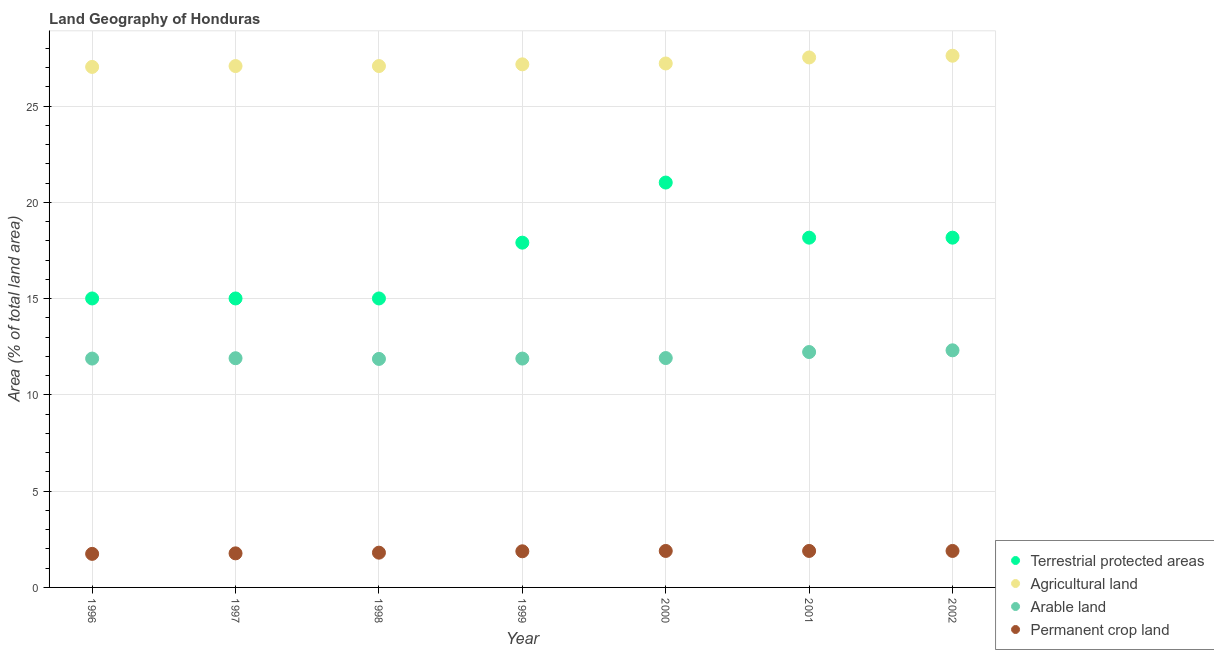How many different coloured dotlines are there?
Give a very brief answer. 4. What is the percentage of area under permanent crop land in 1997?
Offer a very short reply. 1.77. Across all years, what is the maximum percentage of area under arable land?
Your answer should be very brief. 12.32. Across all years, what is the minimum percentage of land under terrestrial protection?
Provide a short and direct response. 15.01. In which year was the percentage of area under agricultural land maximum?
Offer a very short reply. 2002. In which year was the percentage of area under permanent crop land minimum?
Provide a short and direct response. 1996. What is the total percentage of land under terrestrial protection in the graph?
Your answer should be very brief. 120.3. What is the difference between the percentage of area under arable land in 1998 and that in 2001?
Provide a succinct answer. -0.36. What is the difference between the percentage of area under permanent crop land in 1996 and the percentage of land under terrestrial protection in 1998?
Make the answer very short. -13.27. What is the average percentage of land under terrestrial protection per year?
Offer a terse response. 17.19. In the year 1999, what is the difference between the percentage of land under terrestrial protection and percentage of area under arable land?
Make the answer very short. 6.02. In how many years, is the percentage of area under permanent crop land greater than 16 %?
Make the answer very short. 0. What is the ratio of the percentage of area under permanent crop land in 1998 to that in 2001?
Your answer should be very brief. 0.95. Is the difference between the percentage of land under terrestrial protection in 1997 and 2001 greater than the difference between the percentage of area under agricultural land in 1997 and 2001?
Ensure brevity in your answer.  No. What is the difference between the highest and the second highest percentage of land under terrestrial protection?
Provide a succinct answer. 2.86. What is the difference between the highest and the lowest percentage of land under terrestrial protection?
Ensure brevity in your answer.  6.02. Is it the case that in every year, the sum of the percentage of land under terrestrial protection and percentage of area under permanent crop land is greater than the sum of percentage of area under agricultural land and percentage of area under arable land?
Offer a terse response. No. Is it the case that in every year, the sum of the percentage of land under terrestrial protection and percentage of area under agricultural land is greater than the percentage of area under arable land?
Make the answer very short. Yes. Does the percentage of area under arable land monotonically increase over the years?
Give a very brief answer. No. Is the percentage of land under terrestrial protection strictly less than the percentage of area under permanent crop land over the years?
Give a very brief answer. No. What is the difference between two consecutive major ticks on the Y-axis?
Your answer should be very brief. 5. Does the graph contain any zero values?
Make the answer very short. No. Does the graph contain grids?
Give a very brief answer. Yes. Where does the legend appear in the graph?
Ensure brevity in your answer.  Bottom right. How many legend labels are there?
Provide a short and direct response. 4. How are the legend labels stacked?
Ensure brevity in your answer.  Vertical. What is the title of the graph?
Keep it short and to the point. Land Geography of Honduras. What is the label or title of the X-axis?
Make the answer very short. Year. What is the label or title of the Y-axis?
Give a very brief answer. Area (% of total land area). What is the Area (% of total land area) of Terrestrial protected areas in 1996?
Offer a terse response. 15.01. What is the Area (% of total land area) in Agricultural land in 1996?
Make the answer very short. 27.04. What is the Area (% of total land area) of Arable land in 1996?
Your answer should be very brief. 11.89. What is the Area (% of total land area) in Permanent crop land in 1996?
Your answer should be very brief. 1.74. What is the Area (% of total land area) of Terrestrial protected areas in 1997?
Ensure brevity in your answer.  15.01. What is the Area (% of total land area) in Agricultural land in 1997?
Offer a terse response. 27.08. What is the Area (% of total land area) in Arable land in 1997?
Offer a terse response. 11.9. What is the Area (% of total land area) in Permanent crop land in 1997?
Provide a succinct answer. 1.77. What is the Area (% of total land area) of Terrestrial protected areas in 1998?
Ensure brevity in your answer.  15.01. What is the Area (% of total land area) of Agricultural land in 1998?
Give a very brief answer. 27.08. What is the Area (% of total land area) in Arable land in 1998?
Provide a succinct answer. 11.87. What is the Area (% of total land area) of Permanent crop land in 1998?
Make the answer very short. 1.81. What is the Area (% of total land area) of Terrestrial protected areas in 1999?
Your response must be concise. 17.91. What is the Area (% of total land area) in Agricultural land in 1999?
Give a very brief answer. 27.17. What is the Area (% of total land area) of Arable land in 1999?
Ensure brevity in your answer.  11.89. What is the Area (% of total land area) of Permanent crop land in 1999?
Provide a short and direct response. 1.88. What is the Area (% of total land area) in Terrestrial protected areas in 2000?
Make the answer very short. 21.03. What is the Area (% of total land area) in Agricultural land in 2000?
Offer a very short reply. 27.21. What is the Area (% of total land area) in Arable land in 2000?
Your answer should be very brief. 11.91. What is the Area (% of total land area) of Permanent crop land in 2000?
Your answer should be very brief. 1.89. What is the Area (% of total land area) of Terrestrial protected areas in 2001?
Give a very brief answer. 18.17. What is the Area (% of total land area) in Agricultural land in 2001?
Offer a terse response. 27.53. What is the Area (% of total land area) in Arable land in 2001?
Your answer should be very brief. 12.23. What is the Area (% of total land area) of Permanent crop land in 2001?
Keep it short and to the point. 1.89. What is the Area (% of total land area) in Terrestrial protected areas in 2002?
Give a very brief answer. 18.17. What is the Area (% of total land area) in Agricultural land in 2002?
Your answer should be compact. 27.62. What is the Area (% of total land area) of Arable land in 2002?
Your answer should be compact. 12.32. What is the Area (% of total land area) in Permanent crop land in 2002?
Your response must be concise. 1.89. Across all years, what is the maximum Area (% of total land area) in Terrestrial protected areas?
Make the answer very short. 21.03. Across all years, what is the maximum Area (% of total land area) in Agricultural land?
Keep it short and to the point. 27.62. Across all years, what is the maximum Area (% of total land area) in Arable land?
Give a very brief answer. 12.32. Across all years, what is the maximum Area (% of total land area) of Permanent crop land?
Your answer should be very brief. 1.89. Across all years, what is the minimum Area (% of total land area) of Terrestrial protected areas?
Offer a very short reply. 15.01. Across all years, what is the minimum Area (% of total land area) of Agricultural land?
Your response must be concise. 27.04. Across all years, what is the minimum Area (% of total land area) in Arable land?
Make the answer very short. 11.87. Across all years, what is the minimum Area (% of total land area) in Permanent crop land?
Your answer should be compact. 1.74. What is the total Area (% of total land area) in Terrestrial protected areas in the graph?
Provide a succinct answer. 120.3. What is the total Area (% of total land area) in Agricultural land in the graph?
Keep it short and to the point. 190.72. What is the total Area (% of total land area) of Arable land in the graph?
Give a very brief answer. 84. What is the total Area (% of total land area) in Permanent crop land in the graph?
Provide a succinct answer. 12.88. What is the difference between the Area (% of total land area) of Agricultural land in 1996 and that in 1997?
Ensure brevity in your answer.  -0.04. What is the difference between the Area (% of total land area) in Arable land in 1996 and that in 1997?
Offer a terse response. -0.02. What is the difference between the Area (% of total land area) of Permanent crop land in 1996 and that in 1997?
Provide a succinct answer. -0.03. What is the difference between the Area (% of total land area) of Terrestrial protected areas in 1996 and that in 1998?
Give a very brief answer. 0. What is the difference between the Area (% of total land area) in Agricultural land in 1996 and that in 1998?
Make the answer very short. -0.04. What is the difference between the Area (% of total land area) in Arable land in 1996 and that in 1998?
Ensure brevity in your answer.  0.02. What is the difference between the Area (% of total land area) of Permanent crop land in 1996 and that in 1998?
Offer a terse response. -0.06. What is the difference between the Area (% of total land area) of Terrestrial protected areas in 1996 and that in 1999?
Keep it short and to the point. -2.9. What is the difference between the Area (% of total land area) of Agricultural land in 1996 and that in 1999?
Your answer should be very brief. -0.13. What is the difference between the Area (% of total land area) of Permanent crop land in 1996 and that in 1999?
Your response must be concise. -0.13. What is the difference between the Area (% of total land area) of Terrestrial protected areas in 1996 and that in 2000?
Offer a very short reply. -6.02. What is the difference between the Area (% of total land area) in Agricultural land in 1996 and that in 2000?
Keep it short and to the point. -0.18. What is the difference between the Area (% of total land area) of Arable land in 1996 and that in 2000?
Your response must be concise. -0.03. What is the difference between the Area (% of total land area) of Permanent crop land in 1996 and that in 2000?
Keep it short and to the point. -0.15. What is the difference between the Area (% of total land area) of Terrestrial protected areas in 1996 and that in 2001?
Offer a terse response. -3.16. What is the difference between the Area (% of total land area) of Agricultural land in 1996 and that in 2001?
Make the answer very short. -0.49. What is the difference between the Area (% of total land area) of Arable land in 1996 and that in 2001?
Make the answer very short. -0.34. What is the difference between the Area (% of total land area) of Permanent crop land in 1996 and that in 2001?
Provide a short and direct response. -0.15. What is the difference between the Area (% of total land area) of Terrestrial protected areas in 1996 and that in 2002?
Offer a very short reply. -3.16. What is the difference between the Area (% of total land area) of Agricultural land in 1996 and that in 2002?
Give a very brief answer. -0.58. What is the difference between the Area (% of total land area) of Arable land in 1996 and that in 2002?
Your answer should be compact. -0.43. What is the difference between the Area (% of total land area) in Permanent crop land in 1996 and that in 2002?
Provide a succinct answer. -0.15. What is the difference between the Area (% of total land area) in Terrestrial protected areas in 1997 and that in 1998?
Make the answer very short. 0. What is the difference between the Area (% of total land area) in Agricultural land in 1997 and that in 1998?
Provide a short and direct response. 0. What is the difference between the Area (% of total land area) in Arable land in 1997 and that in 1998?
Keep it short and to the point. 0.04. What is the difference between the Area (% of total land area) in Permanent crop land in 1997 and that in 1998?
Offer a terse response. -0.04. What is the difference between the Area (% of total land area) in Terrestrial protected areas in 1997 and that in 1999?
Your answer should be very brief. -2.9. What is the difference between the Area (% of total land area) of Agricultural land in 1997 and that in 1999?
Offer a very short reply. -0.09. What is the difference between the Area (% of total land area) in Arable land in 1997 and that in 1999?
Your answer should be compact. 0.02. What is the difference between the Area (% of total land area) of Permanent crop land in 1997 and that in 1999?
Ensure brevity in your answer.  -0.11. What is the difference between the Area (% of total land area) in Terrestrial protected areas in 1997 and that in 2000?
Your answer should be compact. -6.02. What is the difference between the Area (% of total land area) in Agricultural land in 1997 and that in 2000?
Provide a succinct answer. -0.13. What is the difference between the Area (% of total land area) of Arable land in 1997 and that in 2000?
Your response must be concise. -0.01. What is the difference between the Area (% of total land area) of Permanent crop land in 1997 and that in 2000?
Offer a very short reply. -0.13. What is the difference between the Area (% of total land area) in Terrestrial protected areas in 1997 and that in 2001?
Your answer should be very brief. -3.16. What is the difference between the Area (% of total land area) in Agricultural land in 1997 and that in 2001?
Your answer should be very brief. -0.45. What is the difference between the Area (% of total land area) in Arable land in 1997 and that in 2001?
Your answer should be compact. -0.32. What is the difference between the Area (% of total land area) in Permanent crop land in 1997 and that in 2001?
Provide a short and direct response. -0.13. What is the difference between the Area (% of total land area) of Terrestrial protected areas in 1997 and that in 2002?
Provide a short and direct response. -3.16. What is the difference between the Area (% of total land area) of Agricultural land in 1997 and that in 2002?
Make the answer very short. -0.54. What is the difference between the Area (% of total land area) in Arable land in 1997 and that in 2002?
Offer a very short reply. -0.41. What is the difference between the Area (% of total land area) in Permanent crop land in 1997 and that in 2002?
Make the answer very short. -0.13. What is the difference between the Area (% of total land area) of Terrestrial protected areas in 1998 and that in 1999?
Ensure brevity in your answer.  -2.9. What is the difference between the Area (% of total land area) of Agricultural land in 1998 and that in 1999?
Keep it short and to the point. -0.09. What is the difference between the Area (% of total land area) in Arable land in 1998 and that in 1999?
Ensure brevity in your answer.  -0.02. What is the difference between the Area (% of total land area) in Permanent crop land in 1998 and that in 1999?
Give a very brief answer. -0.07. What is the difference between the Area (% of total land area) in Terrestrial protected areas in 1998 and that in 2000?
Provide a succinct answer. -6.02. What is the difference between the Area (% of total land area) of Agricultural land in 1998 and that in 2000?
Provide a short and direct response. -0.13. What is the difference between the Area (% of total land area) of Arable land in 1998 and that in 2000?
Give a very brief answer. -0.04. What is the difference between the Area (% of total land area) in Permanent crop land in 1998 and that in 2000?
Provide a short and direct response. -0.09. What is the difference between the Area (% of total land area) in Terrestrial protected areas in 1998 and that in 2001?
Make the answer very short. -3.16. What is the difference between the Area (% of total land area) in Agricultural land in 1998 and that in 2001?
Your answer should be compact. -0.45. What is the difference between the Area (% of total land area) in Arable land in 1998 and that in 2001?
Your answer should be very brief. -0.36. What is the difference between the Area (% of total land area) of Permanent crop land in 1998 and that in 2001?
Make the answer very short. -0.09. What is the difference between the Area (% of total land area) of Terrestrial protected areas in 1998 and that in 2002?
Offer a very short reply. -3.16. What is the difference between the Area (% of total land area) of Agricultural land in 1998 and that in 2002?
Your response must be concise. -0.54. What is the difference between the Area (% of total land area) of Arable land in 1998 and that in 2002?
Provide a short and direct response. -0.45. What is the difference between the Area (% of total land area) in Permanent crop land in 1998 and that in 2002?
Your answer should be very brief. -0.09. What is the difference between the Area (% of total land area) in Terrestrial protected areas in 1999 and that in 2000?
Your answer should be very brief. -3.12. What is the difference between the Area (% of total land area) of Agricultural land in 1999 and that in 2000?
Make the answer very short. -0.04. What is the difference between the Area (% of total land area) of Arable land in 1999 and that in 2000?
Offer a very short reply. -0.03. What is the difference between the Area (% of total land area) in Permanent crop land in 1999 and that in 2000?
Provide a short and direct response. -0.02. What is the difference between the Area (% of total land area) in Terrestrial protected areas in 1999 and that in 2001?
Keep it short and to the point. -0.26. What is the difference between the Area (% of total land area) in Agricultural land in 1999 and that in 2001?
Provide a short and direct response. -0.36. What is the difference between the Area (% of total land area) in Arable land in 1999 and that in 2001?
Your response must be concise. -0.34. What is the difference between the Area (% of total land area) in Permanent crop land in 1999 and that in 2001?
Offer a very short reply. -0.02. What is the difference between the Area (% of total land area) of Terrestrial protected areas in 1999 and that in 2002?
Offer a terse response. -0.26. What is the difference between the Area (% of total land area) of Agricultural land in 1999 and that in 2002?
Provide a succinct answer. -0.45. What is the difference between the Area (% of total land area) of Arable land in 1999 and that in 2002?
Provide a succinct answer. -0.43. What is the difference between the Area (% of total land area) of Permanent crop land in 1999 and that in 2002?
Provide a succinct answer. -0.02. What is the difference between the Area (% of total land area) of Terrestrial protected areas in 2000 and that in 2001?
Provide a succinct answer. 2.86. What is the difference between the Area (% of total land area) in Agricultural land in 2000 and that in 2001?
Keep it short and to the point. -0.31. What is the difference between the Area (% of total land area) of Arable land in 2000 and that in 2001?
Your answer should be very brief. -0.31. What is the difference between the Area (% of total land area) of Terrestrial protected areas in 2000 and that in 2002?
Provide a short and direct response. 2.86. What is the difference between the Area (% of total land area) in Agricultural land in 2000 and that in 2002?
Give a very brief answer. -0.4. What is the difference between the Area (% of total land area) in Arable land in 2000 and that in 2002?
Provide a succinct answer. -0.4. What is the difference between the Area (% of total land area) in Permanent crop land in 2000 and that in 2002?
Keep it short and to the point. 0. What is the difference between the Area (% of total land area) of Terrestrial protected areas in 2001 and that in 2002?
Your answer should be very brief. 0. What is the difference between the Area (% of total land area) of Agricultural land in 2001 and that in 2002?
Your response must be concise. -0.09. What is the difference between the Area (% of total land area) of Arable land in 2001 and that in 2002?
Your answer should be very brief. -0.09. What is the difference between the Area (% of total land area) of Terrestrial protected areas in 1996 and the Area (% of total land area) of Agricultural land in 1997?
Provide a short and direct response. -12.07. What is the difference between the Area (% of total land area) of Terrestrial protected areas in 1996 and the Area (% of total land area) of Arable land in 1997?
Keep it short and to the point. 3.1. What is the difference between the Area (% of total land area) of Terrestrial protected areas in 1996 and the Area (% of total land area) of Permanent crop land in 1997?
Make the answer very short. 13.24. What is the difference between the Area (% of total land area) of Agricultural land in 1996 and the Area (% of total land area) of Arable land in 1997?
Your answer should be compact. 15.13. What is the difference between the Area (% of total land area) in Agricultural land in 1996 and the Area (% of total land area) in Permanent crop land in 1997?
Provide a short and direct response. 25.27. What is the difference between the Area (% of total land area) of Arable land in 1996 and the Area (% of total land area) of Permanent crop land in 1997?
Ensure brevity in your answer.  10.12. What is the difference between the Area (% of total land area) in Terrestrial protected areas in 1996 and the Area (% of total land area) in Agricultural land in 1998?
Make the answer very short. -12.07. What is the difference between the Area (% of total land area) in Terrestrial protected areas in 1996 and the Area (% of total land area) in Arable land in 1998?
Offer a very short reply. 3.14. What is the difference between the Area (% of total land area) in Terrestrial protected areas in 1996 and the Area (% of total land area) in Permanent crop land in 1998?
Make the answer very short. 13.2. What is the difference between the Area (% of total land area) of Agricultural land in 1996 and the Area (% of total land area) of Arable land in 1998?
Make the answer very short. 15.17. What is the difference between the Area (% of total land area) of Agricultural land in 1996 and the Area (% of total land area) of Permanent crop land in 1998?
Make the answer very short. 25.23. What is the difference between the Area (% of total land area) in Arable land in 1996 and the Area (% of total land area) in Permanent crop land in 1998?
Keep it short and to the point. 10.08. What is the difference between the Area (% of total land area) in Terrestrial protected areas in 1996 and the Area (% of total land area) in Agricultural land in 1999?
Ensure brevity in your answer.  -12.16. What is the difference between the Area (% of total land area) in Terrestrial protected areas in 1996 and the Area (% of total land area) in Arable land in 1999?
Keep it short and to the point. 3.12. What is the difference between the Area (% of total land area) in Terrestrial protected areas in 1996 and the Area (% of total land area) in Permanent crop land in 1999?
Give a very brief answer. 13.13. What is the difference between the Area (% of total land area) in Agricultural land in 1996 and the Area (% of total land area) in Arable land in 1999?
Provide a short and direct response. 15.15. What is the difference between the Area (% of total land area) in Agricultural land in 1996 and the Area (% of total land area) in Permanent crop land in 1999?
Your response must be concise. 25.16. What is the difference between the Area (% of total land area) in Arable land in 1996 and the Area (% of total land area) in Permanent crop land in 1999?
Your answer should be compact. 10.01. What is the difference between the Area (% of total land area) of Terrestrial protected areas in 1996 and the Area (% of total land area) of Agricultural land in 2000?
Make the answer very short. -12.21. What is the difference between the Area (% of total land area) of Terrestrial protected areas in 1996 and the Area (% of total land area) of Arable land in 2000?
Your answer should be compact. 3.1. What is the difference between the Area (% of total land area) in Terrestrial protected areas in 1996 and the Area (% of total land area) in Permanent crop land in 2000?
Your response must be concise. 13.11. What is the difference between the Area (% of total land area) of Agricultural land in 1996 and the Area (% of total land area) of Arable land in 2000?
Provide a short and direct response. 15.12. What is the difference between the Area (% of total land area) of Agricultural land in 1996 and the Area (% of total land area) of Permanent crop land in 2000?
Provide a succinct answer. 25.14. What is the difference between the Area (% of total land area) of Arable land in 1996 and the Area (% of total land area) of Permanent crop land in 2000?
Keep it short and to the point. 9.99. What is the difference between the Area (% of total land area) in Terrestrial protected areas in 1996 and the Area (% of total land area) in Agricultural land in 2001?
Offer a very short reply. -12.52. What is the difference between the Area (% of total land area) in Terrestrial protected areas in 1996 and the Area (% of total land area) in Arable land in 2001?
Give a very brief answer. 2.78. What is the difference between the Area (% of total land area) in Terrestrial protected areas in 1996 and the Area (% of total land area) in Permanent crop land in 2001?
Offer a terse response. 13.11. What is the difference between the Area (% of total land area) of Agricultural land in 1996 and the Area (% of total land area) of Arable land in 2001?
Give a very brief answer. 14.81. What is the difference between the Area (% of total land area) in Agricultural land in 1996 and the Area (% of total land area) in Permanent crop land in 2001?
Provide a short and direct response. 25.14. What is the difference between the Area (% of total land area) in Arable land in 1996 and the Area (% of total land area) in Permanent crop land in 2001?
Offer a very short reply. 9.99. What is the difference between the Area (% of total land area) of Terrestrial protected areas in 1996 and the Area (% of total land area) of Agricultural land in 2002?
Make the answer very short. -12.61. What is the difference between the Area (% of total land area) of Terrestrial protected areas in 1996 and the Area (% of total land area) of Arable land in 2002?
Offer a very short reply. 2.69. What is the difference between the Area (% of total land area) of Terrestrial protected areas in 1996 and the Area (% of total land area) of Permanent crop land in 2002?
Provide a short and direct response. 13.11. What is the difference between the Area (% of total land area) in Agricultural land in 1996 and the Area (% of total land area) in Arable land in 2002?
Offer a very short reply. 14.72. What is the difference between the Area (% of total land area) of Agricultural land in 1996 and the Area (% of total land area) of Permanent crop land in 2002?
Offer a terse response. 25.14. What is the difference between the Area (% of total land area) of Arable land in 1996 and the Area (% of total land area) of Permanent crop land in 2002?
Offer a terse response. 9.99. What is the difference between the Area (% of total land area) of Terrestrial protected areas in 1997 and the Area (% of total land area) of Agricultural land in 1998?
Your response must be concise. -12.07. What is the difference between the Area (% of total land area) in Terrestrial protected areas in 1997 and the Area (% of total land area) in Arable land in 1998?
Your answer should be compact. 3.14. What is the difference between the Area (% of total land area) in Terrestrial protected areas in 1997 and the Area (% of total land area) in Permanent crop land in 1998?
Your answer should be very brief. 13.2. What is the difference between the Area (% of total land area) of Agricultural land in 1997 and the Area (% of total land area) of Arable land in 1998?
Give a very brief answer. 15.21. What is the difference between the Area (% of total land area) in Agricultural land in 1997 and the Area (% of total land area) in Permanent crop land in 1998?
Your answer should be very brief. 25.27. What is the difference between the Area (% of total land area) in Arable land in 1997 and the Area (% of total land area) in Permanent crop land in 1998?
Give a very brief answer. 10.1. What is the difference between the Area (% of total land area) of Terrestrial protected areas in 1997 and the Area (% of total land area) of Agricultural land in 1999?
Ensure brevity in your answer.  -12.16. What is the difference between the Area (% of total land area) of Terrestrial protected areas in 1997 and the Area (% of total land area) of Arable land in 1999?
Your answer should be very brief. 3.12. What is the difference between the Area (% of total land area) in Terrestrial protected areas in 1997 and the Area (% of total land area) in Permanent crop land in 1999?
Make the answer very short. 13.13. What is the difference between the Area (% of total land area) in Agricultural land in 1997 and the Area (% of total land area) in Arable land in 1999?
Provide a short and direct response. 15.19. What is the difference between the Area (% of total land area) of Agricultural land in 1997 and the Area (% of total land area) of Permanent crop land in 1999?
Provide a succinct answer. 25.2. What is the difference between the Area (% of total land area) in Arable land in 1997 and the Area (% of total land area) in Permanent crop land in 1999?
Provide a short and direct response. 10.03. What is the difference between the Area (% of total land area) in Terrestrial protected areas in 1997 and the Area (% of total land area) in Agricultural land in 2000?
Ensure brevity in your answer.  -12.21. What is the difference between the Area (% of total land area) in Terrestrial protected areas in 1997 and the Area (% of total land area) in Arable land in 2000?
Your answer should be compact. 3.1. What is the difference between the Area (% of total land area) in Terrestrial protected areas in 1997 and the Area (% of total land area) in Permanent crop land in 2000?
Your answer should be compact. 13.11. What is the difference between the Area (% of total land area) in Agricultural land in 1997 and the Area (% of total land area) in Arable land in 2000?
Give a very brief answer. 15.17. What is the difference between the Area (% of total land area) in Agricultural land in 1997 and the Area (% of total land area) in Permanent crop land in 2000?
Your response must be concise. 25.19. What is the difference between the Area (% of total land area) in Arable land in 1997 and the Area (% of total land area) in Permanent crop land in 2000?
Your answer should be very brief. 10.01. What is the difference between the Area (% of total land area) in Terrestrial protected areas in 1997 and the Area (% of total land area) in Agricultural land in 2001?
Your answer should be very brief. -12.52. What is the difference between the Area (% of total land area) in Terrestrial protected areas in 1997 and the Area (% of total land area) in Arable land in 2001?
Offer a very short reply. 2.78. What is the difference between the Area (% of total land area) of Terrestrial protected areas in 1997 and the Area (% of total land area) of Permanent crop land in 2001?
Your answer should be compact. 13.11. What is the difference between the Area (% of total land area) in Agricultural land in 1997 and the Area (% of total land area) in Arable land in 2001?
Give a very brief answer. 14.85. What is the difference between the Area (% of total land area) in Agricultural land in 1997 and the Area (% of total land area) in Permanent crop land in 2001?
Your answer should be compact. 25.19. What is the difference between the Area (% of total land area) in Arable land in 1997 and the Area (% of total land area) in Permanent crop land in 2001?
Make the answer very short. 10.01. What is the difference between the Area (% of total land area) in Terrestrial protected areas in 1997 and the Area (% of total land area) in Agricultural land in 2002?
Your answer should be compact. -12.61. What is the difference between the Area (% of total land area) of Terrestrial protected areas in 1997 and the Area (% of total land area) of Arable land in 2002?
Offer a terse response. 2.69. What is the difference between the Area (% of total land area) of Terrestrial protected areas in 1997 and the Area (% of total land area) of Permanent crop land in 2002?
Your answer should be compact. 13.11. What is the difference between the Area (% of total land area) of Agricultural land in 1997 and the Area (% of total land area) of Arable land in 2002?
Your answer should be very brief. 14.76. What is the difference between the Area (% of total land area) in Agricultural land in 1997 and the Area (% of total land area) in Permanent crop land in 2002?
Make the answer very short. 25.19. What is the difference between the Area (% of total land area) in Arable land in 1997 and the Area (% of total land area) in Permanent crop land in 2002?
Make the answer very short. 10.01. What is the difference between the Area (% of total land area) of Terrestrial protected areas in 1998 and the Area (% of total land area) of Agricultural land in 1999?
Ensure brevity in your answer.  -12.16. What is the difference between the Area (% of total land area) of Terrestrial protected areas in 1998 and the Area (% of total land area) of Arable land in 1999?
Provide a short and direct response. 3.12. What is the difference between the Area (% of total land area) in Terrestrial protected areas in 1998 and the Area (% of total land area) in Permanent crop land in 1999?
Offer a terse response. 13.13. What is the difference between the Area (% of total land area) in Agricultural land in 1998 and the Area (% of total land area) in Arable land in 1999?
Your response must be concise. 15.19. What is the difference between the Area (% of total land area) in Agricultural land in 1998 and the Area (% of total land area) in Permanent crop land in 1999?
Offer a terse response. 25.2. What is the difference between the Area (% of total land area) in Arable land in 1998 and the Area (% of total land area) in Permanent crop land in 1999?
Keep it short and to the point. 9.99. What is the difference between the Area (% of total land area) in Terrestrial protected areas in 1998 and the Area (% of total land area) in Agricultural land in 2000?
Your response must be concise. -12.21. What is the difference between the Area (% of total land area) of Terrestrial protected areas in 1998 and the Area (% of total land area) of Arable land in 2000?
Provide a succinct answer. 3.1. What is the difference between the Area (% of total land area) in Terrestrial protected areas in 1998 and the Area (% of total land area) in Permanent crop land in 2000?
Keep it short and to the point. 13.11. What is the difference between the Area (% of total land area) of Agricultural land in 1998 and the Area (% of total land area) of Arable land in 2000?
Keep it short and to the point. 15.17. What is the difference between the Area (% of total land area) of Agricultural land in 1998 and the Area (% of total land area) of Permanent crop land in 2000?
Ensure brevity in your answer.  25.19. What is the difference between the Area (% of total land area) of Arable land in 1998 and the Area (% of total land area) of Permanent crop land in 2000?
Provide a succinct answer. 9.97. What is the difference between the Area (% of total land area) in Terrestrial protected areas in 1998 and the Area (% of total land area) in Agricultural land in 2001?
Provide a succinct answer. -12.52. What is the difference between the Area (% of total land area) of Terrestrial protected areas in 1998 and the Area (% of total land area) of Arable land in 2001?
Offer a terse response. 2.78. What is the difference between the Area (% of total land area) of Terrestrial protected areas in 1998 and the Area (% of total land area) of Permanent crop land in 2001?
Your answer should be very brief. 13.11. What is the difference between the Area (% of total land area) of Agricultural land in 1998 and the Area (% of total land area) of Arable land in 2001?
Your answer should be compact. 14.85. What is the difference between the Area (% of total land area) in Agricultural land in 1998 and the Area (% of total land area) in Permanent crop land in 2001?
Offer a very short reply. 25.19. What is the difference between the Area (% of total land area) in Arable land in 1998 and the Area (% of total land area) in Permanent crop land in 2001?
Your answer should be compact. 9.97. What is the difference between the Area (% of total land area) in Terrestrial protected areas in 1998 and the Area (% of total land area) in Agricultural land in 2002?
Give a very brief answer. -12.61. What is the difference between the Area (% of total land area) of Terrestrial protected areas in 1998 and the Area (% of total land area) of Arable land in 2002?
Your answer should be compact. 2.69. What is the difference between the Area (% of total land area) of Terrestrial protected areas in 1998 and the Area (% of total land area) of Permanent crop land in 2002?
Provide a succinct answer. 13.11. What is the difference between the Area (% of total land area) in Agricultural land in 1998 and the Area (% of total land area) in Arable land in 2002?
Your response must be concise. 14.76. What is the difference between the Area (% of total land area) of Agricultural land in 1998 and the Area (% of total land area) of Permanent crop land in 2002?
Provide a short and direct response. 25.19. What is the difference between the Area (% of total land area) of Arable land in 1998 and the Area (% of total land area) of Permanent crop land in 2002?
Offer a terse response. 9.97. What is the difference between the Area (% of total land area) in Terrestrial protected areas in 1999 and the Area (% of total land area) in Agricultural land in 2000?
Offer a terse response. -9.31. What is the difference between the Area (% of total land area) in Terrestrial protected areas in 1999 and the Area (% of total land area) in Arable land in 2000?
Your response must be concise. 5.99. What is the difference between the Area (% of total land area) of Terrestrial protected areas in 1999 and the Area (% of total land area) of Permanent crop land in 2000?
Your response must be concise. 16.01. What is the difference between the Area (% of total land area) of Agricultural land in 1999 and the Area (% of total land area) of Arable land in 2000?
Your answer should be compact. 15.26. What is the difference between the Area (% of total land area) of Agricultural land in 1999 and the Area (% of total land area) of Permanent crop land in 2000?
Your answer should be very brief. 25.27. What is the difference between the Area (% of total land area) of Arable land in 1999 and the Area (% of total land area) of Permanent crop land in 2000?
Provide a short and direct response. 9.99. What is the difference between the Area (% of total land area) in Terrestrial protected areas in 1999 and the Area (% of total land area) in Agricultural land in 2001?
Your answer should be very brief. -9.62. What is the difference between the Area (% of total land area) of Terrestrial protected areas in 1999 and the Area (% of total land area) of Arable land in 2001?
Offer a terse response. 5.68. What is the difference between the Area (% of total land area) in Terrestrial protected areas in 1999 and the Area (% of total land area) in Permanent crop land in 2001?
Provide a short and direct response. 16.01. What is the difference between the Area (% of total land area) of Agricultural land in 1999 and the Area (% of total land area) of Arable land in 2001?
Keep it short and to the point. 14.94. What is the difference between the Area (% of total land area) of Agricultural land in 1999 and the Area (% of total land area) of Permanent crop land in 2001?
Give a very brief answer. 25.27. What is the difference between the Area (% of total land area) in Arable land in 1999 and the Area (% of total land area) in Permanent crop land in 2001?
Provide a short and direct response. 9.99. What is the difference between the Area (% of total land area) in Terrestrial protected areas in 1999 and the Area (% of total land area) in Agricultural land in 2002?
Your answer should be very brief. -9.71. What is the difference between the Area (% of total land area) of Terrestrial protected areas in 1999 and the Area (% of total land area) of Arable land in 2002?
Your answer should be compact. 5.59. What is the difference between the Area (% of total land area) of Terrestrial protected areas in 1999 and the Area (% of total land area) of Permanent crop land in 2002?
Make the answer very short. 16.01. What is the difference between the Area (% of total land area) of Agricultural land in 1999 and the Area (% of total land area) of Arable land in 2002?
Offer a terse response. 14.85. What is the difference between the Area (% of total land area) in Agricultural land in 1999 and the Area (% of total land area) in Permanent crop land in 2002?
Your answer should be very brief. 25.27. What is the difference between the Area (% of total land area) of Arable land in 1999 and the Area (% of total land area) of Permanent crop land in 2002?
Your answer should be compact. 9.99. What is the difference between the Area (% of total land area) in Terrestrial protected areas in 2000 and the Area (% of total land area) in Agricultural land in 2001?
Keep it short and to the point. -6.5. What is the difference between the Area (% of total land area) in Terrestrial protected areas in 2000 and the Area (% of total land area) in Arable land in 2001?
Keep it short and to the point. 8.8. What is the difference between the Area (% of total land area) of Terrestrial protected areas in 2000 and the Area (% of total land area) of Permanent crop land in 2001?
Your response must be concise. 19.13. What is the difference between the Area (% of total land area) of Agricultural land in 2000 and the Area (% of total land area) of Arable land in 2001?
Your response must be concise. 14.99. What is the difference between the Area (% of total land area) of Agricultural land in 2000 and the Area (% of total land area) of Permanent crop land in 2001?
Offer a very short reply. 25.32. What is the difference between the Area (% of total land area) of Arable land in 2000 and the Area (% of total land area) of Permanent crop land in 2001?
Offer a very short reply. 10.02. What is the difference between the Area (% of total land area) of Terrestrial protected areas in 2000 and the Area (% of total land area) of Agricultural land in 2002?
Your answer should be compact. -6.59. What is the difference between the Area (% of total land area) of Terrestrial protected areas in 2000 and the Area (% of total land area) of Arable land in 2002?
Provide a short and direct response. 8.71. What is the difference between the Area (% of total land area) of Terrestrial protected areas in 2000 and the Area (% of total land area) of Permanent crop land in 2002?
Provide a short and direct response. 19.13. What is the difference between the Area (% of total land area) of Agricultural land in 2000 and the Area (% of total land area) of Arable land in 2002?
Your response must be concise. 14.9. What is the difference between the Area (% of total land area) of Agricultural land in 2000 and the Area (% of total land area) of Permanent crop land in 2002?
Keep it short and to the point. 25.32. What is the difference between the Area (% of total land area) of Arable land in 2000 and the Area (% of total land area) of Permanent crop land in 2002?
Offer a terse response. 10.02. What is the difference between the Area (% of total land area) in Terrestrial protected areas in 2001 and the Area (% of total land area) in Agricultural land in 2002?
Your answer should be compact. -9.45. What is the difference between the Area (% of total land area) in Terrestrial protected areas in 2001 and the Area (% of total land area) in Arable land in 2002?
Provide a succinct answer. 5.85. What is the difference between the Area (% of total land area) of Terrestrial protected areas in 2001 and the Area (% of total land area) of Permanent crop land in 2002?
Your response must be concise. 16.27. What is the difference between the Area (% of total land area) of Agricultural land in 2001 and the Area (% of total land area) of Arable land in 2002?
Provide a short and direct response. 15.21. What is the difference between the Area (% of total land area) in Agricultural land in 2001 and the Area (% of total land area) in Permanent crop land in 2002?
Give a very brief answer. 25.63. What is the difference between the Area (% of total land area) of Arable land in 2001 and the Area (% of total land area) of Permanent crop land in 2002?
Make the answer very short. 10.33. What is the average Area (% of total land area) of Terrestrial protected areas per year?
Your answer should be very brief. 17.19. What is the average Area (% of total land area) of Agricultural land per year?
Give a very brief answer. 27.25. What is the average Area (% of total land area) of Arable land per year?
Your answer should be compact. 12. What is the average Area (% of total land area) of Permanent crop land per year?
Provide a succinct answer. 1.84. In the year 1996, what is the difference between the Area (% of total land area) of Terrestrial protected areas and Area (% of total land area) of Agricultural land?
Provide a short and direct response. -12.03. In the year 1996, what is the difference between the Area (% of total land area) of Terrestrial protected areas and Area (% of total land area) of Arable land?
Offer a terse response. 3.12. In the year 1996, what is the difference between the Area (% of total land area) in Terrestrial protected areas and Area (% of total land area) in Permanent crop land?
Offer a terse response. 13.27. In the year 1996, what is the difference between the Area (% of total land area) of Agricultural land and Area (% of total land area) of Arable land?
Your answer should be compact. 15.15. In the year 1996, what is the difference between the Area (% of total land area) in Agricultural land and Area (% of total land area) in Permanent crop land?
Offer a very short reply. 25.29. In the year 1996, what is the difference between the Area (% of total land area) in Arable land and Area (% of total land area) in Permanent crop land?
Offer a very short reply. 10.14. In the year 1997, what is the difference between the Area (% of total land area) in Terrestrial protected areas and Area (% of total land area) in Agricultural land?
Make the answer very short. -12.07. In the year 1997, what is the difference between the Area (% of total land area) in Terrestrial protected areas and Area (% of total land area) in Arable land?
Provide a short and direct response. 3.1. In the year 1997, what is the difference between the Area (% of total land area) in Terrestrial protected areas and Area (% of total land area) in Permanent crop land?
Your answer should be very brief. 13.24. In the year 1997, what is the difference between the Area (% of total land area) in Agricultural land and Area (% of total land area) in Arable land?
Make the answer very short. 15.18. In the year 1997, what is the difference between the Area (% of total land area) of Agricultural land and Area (% of total land area) of Permanent crop land?
Ensure brevity in your answer.  25.31. In the year 1997, what is the difference between the Area (% of total land area) of Arable land and Area (% of total land area) of Permanent crop land?
Make the answer very short. 10.13. In the year 1998, what is the difference between the Area (% of total land area) in Terrestrial protected areas and Area (% of total land area) in Agricultural land?
Ensure brevity in your answer.  -12.07. In the year 1998, what is the difference between the Area (% of total land area) in Terrestrial protected areas and Area (% of total land area) in Arable land?
Make the answer very short. 3.14. In the year 1998, what is the difference between the Area (% of total land area) of Terrestrial protected areas and Area (% of total land area) of Permanent crop land?
Make the answer very short. 13.2. In the year 1998, what is the difference between the Area (% of total land area) of Agricultural land and Area (% of total land area) of Arable land?
Your response must be concise. 15.21. In the year 1998, what is the difference between the Area (% of total land area) in Agricultural land and Area (% of total land area) in Permanent crop land?
Your answer should be compact. 25.27. In the year 1998, what is the difference between the Area (% of total land area) in Arable land and Area (% of total land area) in Permanent crop land?
Keep it short and to the point. 10.06. In the year 1999, what is the difference between the Area (% of total land area) of Terrestrial protected areas and Area (% of total land area) of Agricultural land?
Give a very brief answer. -9.26. In the year 1999, what is the difference between the Area (% of total land area) in Terrestrial protected areas and Area (% of total land area) in Arable land?
Keep it short and to the point. 6.02. In the year 1999, what is the difference between the Area (% of total land area) of Terrestrial protected areas and Area (% of total land area) of Permanent crop land?
Offer a terse response. 16.03. In the year 1999, what is the difference between the Area (% of total land area) in Agricultural land and Area (% of total land area) in Arable land?
Offer a very short reply. 15.28. In the year 1999, what is the difference between the Area (% of total land area) of Agricultural land and Area (% of total land area) of Permanent crop land?
Provide a short and direct response. 25.29. In the year 1999, what is the difference between the Area (% of total land area) in Arable land and Area (% of total land area) in Permanent crop land?
Ensure brevity in your answer.  10.01. In the year 2000, what is the difference between the Area (% of total land area) in Terrestrial protected areas and Area (% of total land area) in Agricultural land?
Keep it short and to the point. -6.18. In the year 2000, what is the difference between the Area (% of total land area) in Terrestrial protected areas and Area (% of total land area) in Arable land?
Make the answer very short. 9.12. In the year 2000, what is the difference between the Area (% of total land area) of Terrestrial protected areas and Area (% of total land area) of Permanent crop land?
Your answer should be very brief. 19.13. In the year 2000, what is the difference between the Area (% of total land area) of Agricultural land and Area (% of total land area) of Arable land?
Your answer should be compact. 15.3. In the year 2000, what is the difference between the Area (% of total land area) in Agricultural land and Area (% of total land area) in Permanent crop land?
Make the answer very short. 25.32. In the year 2000, what is the difference between the Area (% of total land area) of Arable land and Area (% of total land area) of Permanent crop land?
Your answer should be compact. 10.02. In the year 2001, what is the difference between the Area (% of total land area) of Terrestrial protected areas and Area (% of total land area) of Agricultural land?
Make the answer very short. -9.36. In the year 2001, what is the difference between the Area (% of total land area) of Terrestrial protected areas and Area (% of total land area) of Arable land?
Provide a short and direct response. 5.94. In the year 2001, what is the difference between the Area (% of total land area) in Terrestrial protected areas and Area (% of total land area) in Permanent crop land?
Provide a short and direct response. 16.27. In the year 2001, what is the difference between the Area (% of total land area) of Agricultural land and Area (% of total land area) of Arable land?
Provide a short and direct response. 15.3. In the year 2001, what is the difference between the Area (% of total land area) in Agricultural land and Area (% of total land area) in Permanent crop land?
Offer a terse response. 25.63. In the year 2001, what is the difference between the Area (% of total land area) of Arable land and Area (% of total land area) of Permanent crop land?
Provide a short and direct response. 10.33. In the year 2002, what is the difference between the Area (% of total land area) in Terrestrial protected areas and Area (% of total land area) in Agricultural land?
Ensure brevity in your answer.  -9.45. In the year 2002, what is the difference between the Area (% of total land area) of Terrestrial protected areas and Area (% of total land area) of Arable land?
Provide a short and direct response. 5.85. In the year 2002, what is the difference between the Area (% of total land area) in Terrestrial protected areas and Area (% of total land area) in Permanent crop land?
Ensure brevity in your answer.  16.27. In the year 2002, what is the difference between the Area (% of total land area) of Agricultural land and Area (% of total land area) of Arable land?
Provide a short and direct response. 15.3. In the year 2002, what is the difference between the Area (% of total land area) in Agricultural land and Area (% of total land area) in Permanent crop land?
Your answer should be compact. 25.72. In the year 2002, what is the difference between the Area (% of total land area) of Arable land and Area (% of total land area) of Permanent crop land?
Your answer should be very brief. 10.42. What is the ratio of the Area (% of total land area) in Arable land in 1996 to that in 1997?
Keep it short and to the point. 1. What is the ratio of the Area (% of total land area) in Agricultural land in 1996 to that in 1998?
Offer a very short reply. 1. What is the ratio of the Area (% of total land area) of Arable land in 1996 to that in 1998?
Offer a very short reply. 1. What is the ratio of the Area (% of total land area) of Permanent crop land in 1996 to that in 1998?
Ensure brevity in your answer.  0.97. What is the ratio of the Area (% of total land area) of Terrestrial protected areas in 1996 to that in 1999?
Provide a short and direct response. 0.84. What is the ratio of the Area (% of total land area) in Agricultural land in 1996 to that in 1999?
Provide a succinct answer. 1. What is the ratio of the Area (% of total land area) in Permanent crop land in 1996 to that in 1999?
Keep it short and to the point. 0.93. What is the ratio of the Area (% of total land area) of Terrestrial protected areas in 1996 to that in 2000?
Keep it short and to the point. 0.71. What is the ratio of the Area (% of total land area) of Agricultural land in 1996 to that in 2000?
Offer a very short reply. 0.99. What is the ratio of the Area (% of total land area) in Permanent crop land in 1996 to that in 2000?
Keep it short and to the point. 0.92. What is the ratio of the Area (% of total land area) in Terrestrial protected areas in 1996 to that in 2001?
Your answer should be very brief. 0.83. What is the ratio of the Area (% of total land area) in Agricultural land in 1996 to that in 2001?
Ensure brevity in your answer.  0.98. What is the ratio of the Area (% of total land area) of Arable land in 1996 to that in 2001?
Provide a short and direct response. 0.97. What is the ratio of the Area (% of total land area) in Permanent crop land in 1996 to that in 2001?
Keep it short and to the point. 0.92. What is the ratio of the Area (% of total land area) of Terrestrial protected areas in 1996 to that in 2002?
Offer a terse response. 0.83. What is the ratio of the Area (% of total land area) in Arable land in 1996 to that in 2002?
Provide a short and direct response. 0.97. What is the ratio of the Area (% of total land area) in Permanent crop land in 1996 to that in 2002?
Keep it short and to the point. 0.92. What is the ratio of the Area (% of total land area) of Agricultural land in 1997 to that in 1998?
Provide a succinct answer. 1. What is the ratio of the Area (% of total land area) of Permanent crop land in 1997 to that in 1998?
Ensure brevity in your answer.  0.98. What is the ratio of the Area (% of total land area) in Terrestrial protected areas in 1997 to that in 1999?
Your answer should be compact. 0.84. What is the ratio of the Area (% of total land area) in Permanent crop land in 1997 to that in 1999?
Your answer should be very brief. 0.94. What is the ratio of the Area (% of total land area) in Terrestrial protected areas in 1997 to that in 2000?
Make the answer very short. 0.71. What is the ratio of the Area (% of total land area) in Permanent crop land in 1997 to that in 2000?
Keep it short and to the point. 0.93. What is the ratio of the Area (% of total land area) in Terrestrial protected areas in 1997 to that in 2001?
Provide a short and direct response. 0.83. What is the ratio of the Area (% of total land area) of Agricultural land in 1997 to that in 2001?
Offer a very short reply. 0.98. What is the ratio of the Area (% of total land area) of Arable land in 1997 to that in 2001?
Offer a very short reply. 0.97. What is the ratio of the Area (% of total land area) of Permanent crop land in 1997 to that in 2001?
Ensure brevity in your answer.  0.93. What is the ratio of the Area (% of total land area) of Terrestrial protected areas in 1997 to that in 2002?
Your response must be concise. 0.83. What is the ratio of the Area (% of total land area) in Agricultural land in 1997 to that in 2002?
Keep it short and to the point. 0.98. What is the ratio of the Area (% of total land area) of Arable land in 1997 to that in 2002?
Keep it short and to the point. 0.97. What is the ratio of the Area (% of total land area) in Permanent crop land in 1997 to that in 2002?
Your answer should be compact. 0.93. What is the ratio of the Area (% of total land area) of Terrestrial protected areas in 1998 to that in 1999?
Provide a succinct answer. 0.84. What is the ratio of the Area (% of total land area) of Agricultural land in 1998 to that in 1999?
Provide a short and direct response. 1. What is the ratio of the Area (% of total land area) of Arable land in 1998 to that in 1999?
Offer a very short reply. 1. What is the ratio of the Area (% of total land area) in Permanent crop land in 1998 to that in 1999?
Your answer should be compact. 0.96. What is the ratio of the Area (% of total land area) of Terrestrial protected areas in 1998 to that in 2000?
Your answer should be compact. 0.71. What is the ratio of the Area (% of total land area) in Permanent crop land in 1998 to that in 2000?
Offer a terse response. 0.95. What is the ratio of the Area (% of total land area) of Terrestrial protected areas in 1998 to that in 2001?
Give a very brief answer. 0.83. What is the ratio of the Area (% of total land area) of Agricultural land in 1998 to that in 2001?
Your response must be concise. 0.98. What is the ratio of the Area (% of total land area) in Arable land in 1998 to that in 2001?
Provide a succinct answer. 0.97. What is the ratio of the Area (% of total land area) in Permanent crop land in 1998 to that in 2001?
Offer a terse response. 0.95. What is the ratio of the Area (% of total land area) of Terrestrial protected areas in 1998 to that in 2002?
Offer a terse response. 0.83. What is the ratio of the Area (% of total land area) of Agricultural land in 1998 to that in 2002?
Offer a very short reply. 0.98. What is the ratio of the Area (% of total land area) of Arable land in 1998 to that in 2002?
Offer a very short reply. 0.96. What is the ratio of the Area (% of total land area) in Permanent crop land in 1998 to that in 2002?
Keep it short and to the point. 0.95. What is the ratio of the Area (% of total land area) in Terrestrial protected areas in 1999 to that in 2000?
Ensure brevity in your answer.  0.85. What is the ratio of the Area (% of total land area) of Permanent crop land in 1999 to that in 2000?
Give a very brief answer. 0.99. What is the ratio of the Area (% of total land area) in Terrestrial protected areas in 1999 to that in 2001?
Give a very brief answer. 0.99. What is the ratio of the Area (% of total land area) in Agricultural land in 1999 to that in 2001?
Ensure brevity in your answer.  0.99. What is the ratio of the Area (% of total land area) of Arable land in 1999 to that in 2001?
Make the answer very short. 0.97. What is the ratio of the Area (% of total land area) in Permanent crop land in 1999 to that in 2001?
Ensure brevity in your answer.  0.99. What is the ratio of the Area (% of total land area) in Terrestrial protected areas in 1999 to that in 2002?
Ensure brevity in your answer.  0.99. What is the ratio of the Area (% of total land area) of Agricultural land in 1999 to that in 2002?
Your answer should be compact. 0.98. What is the ratio of the Area (% of total land area) in Arable land in 1999 to that in 2002?
Provide a short and direct response. 0.97. What is the ratio of the Area (% of total land area) of Permanent crop land in 1999 to that in 2002?
Your answer should be compact. 0.99. What is the ratio of the Area (% of total land area) of Terrestrial protected areas in 2000 to that in 2001?
Make the answer very short. 1.16. What is the ratio of the Area (% of total land area) in Arable land in 2000 to that in 2001?
Provide a succinct answer. 0.97. What is the ratio of the Area (% of total land area) in Terrestrial protected areas in 2000 to that in 2002?
Your response must be concise. 1.16. What is the ratio of the Area (% of total land area) in Agricultural land in 2000 to that in 2002?
Give a very brief answer. 0.99. What is the ratio of the Area (% of total land area) in Arable land in 2000 to that in 2002?
Your answer should be very brief. 0.97. What is the difference between the highest and the second highest Area (% of total land area) in Terrestrial protected areas?
Give a very brief answer. 2.86. What is the difference between the highest and the second highest Area (% of total land area) in Agricultural land?
Your answer should be very brief. 0.09. What is the difference between the highest and the second highest Area (% of total land area) in Arable land?
Provide a succinct answer. 0.09. What is the difference between the highest and the lowest Area (% of total land area) in Terrestrial protected areas?
Ensure brevity in your answer.  6.02. What is the difference between the highest and the lowest Area (% of total land area) in Agricultural land?
Offer a very short reply. 0.58. What is the difference between the highest and the lowest Area (% of total land area) in Arable land?
Your response must be concise. 0.45. What is the difference between the highest and the lowest Area (% of total land area) in Permanent crop land?
Make the answer very short. 0.15. 